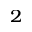<formula> <loc_0><loc_0><loc_500><loc_500>_ { 2 }</formula> 